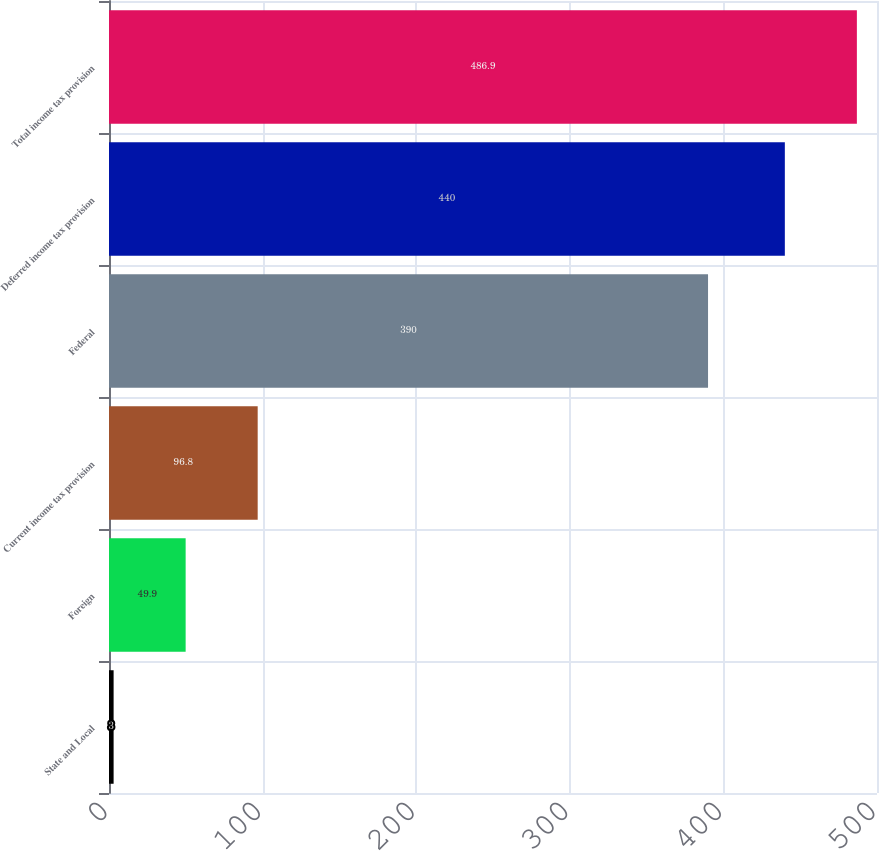Convert chart to OTSL. <chart><loc_0><loc_0><loc_500><loc_500><bar_chart><fcel>State and Local<fcel>Foreign<fcel>Current income tax provision<fcel>Federal<fcel>Deferred income tax provision<fcel>Total income tax provision<nl><fcel>3<fcel>49.9<fcel>96.8<fcel>390<fcel>440<fcel>486.9<nl></chart> 